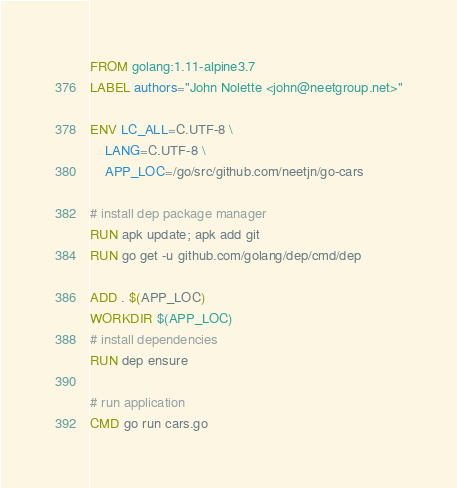Convert code to text. <code><loc_0><loc_0><loc_500><loc_500><_Dockerfile_>FROM golang:1.11-alpine3.7
LABEL authors="John Nolette <john@neetgroup.net>"

ENV LC_ALL=C.UTF-8 \
    LANG=C.UTF-8 \
    APP_LOC=/go/src/github.com/neetjn/go-cars

# install dep package manager
RUN apk update; apk add git
RUN go get -u github.com/golang/dep/cmd/dep

ADD . $(APP_LOC)
WORKDIR $(APP_LOC)
# install dependencies
RUN dep ensure

# run application
CMD go run cars.go
</code> 